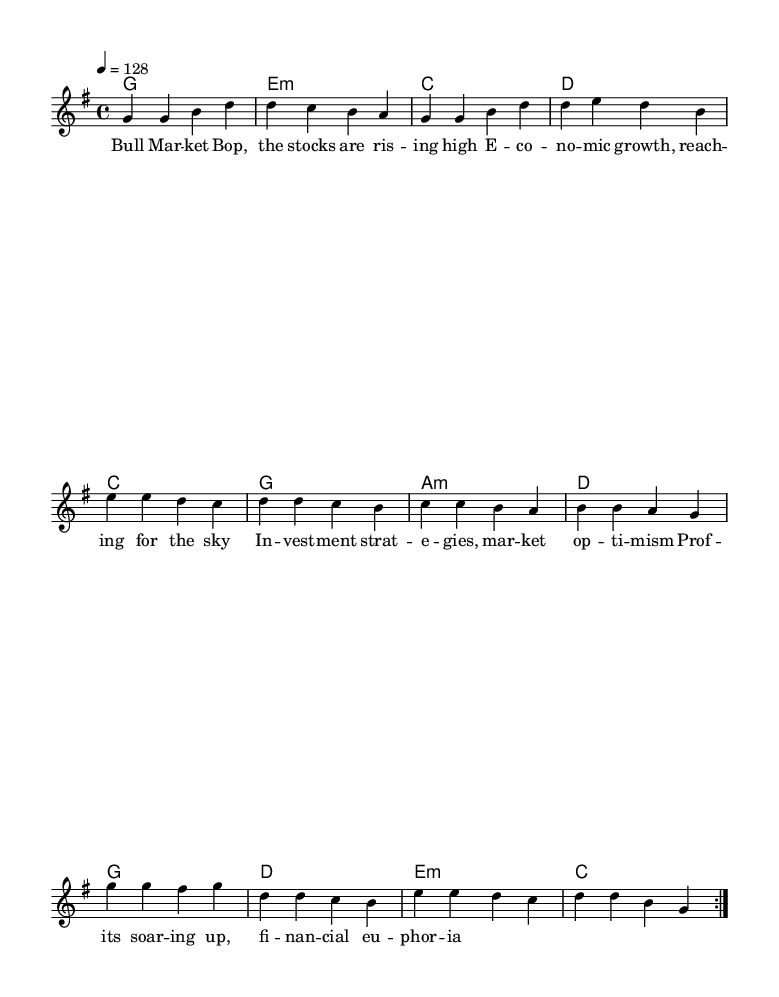What is the key signature of this music? The key signature is G major, which has one sharp (F#). It can be identified by looking at the key signature placed at the beginning of the staff.
Answer: G major What is the time signature of this music? The time signature is 4/4, indicated at the beginning of the score. It means there are four beats per measure, with a quarter note receiving one beat.
Answer: 4/4 What is the tempo of this piece? The tempo is set at 128 beats per minute, as noted at the start of the score. This indicates the speed at which the piece should be played.
Answer: 128 What is the structure of the song? The song consists of three main sections: Verse, Pre-Chorus, and Chorus. Each section is clearly marked and provides a typical K-Pop structure that alternates between melodies and harmonies.
Answer: Verse, Pre-Chorus, Chorus How many times does the verse repeat? The verse is marked to repeat twice, as indicated by the repeat sign (volta) at the beginning of the verse section. This means that the verse is played two times before moving on to the next section.
Answer: 2 What do the lyrics of this song primarily discuss? The lyrics discuss market trends and economic growth, focusing on stock market optimism and investments, which aligns with the theme of economic prosperity. This is typical in K-Pop anthems that aim to inspire and motivate listeners.
Answer: Market trends and economic growth What is the ending chord of the chorus? The ending chord of the chorus is G major, which is indicated at the end of the chorus section. This final chord often resolves the musical phrases, providing a sense of closure.
Answer: G 